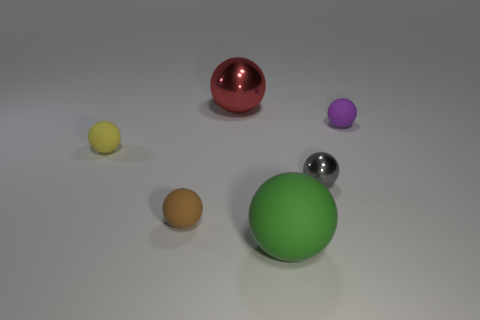Subtract 1 balls. How many balls are left? 5 Subtract all gray spheres. How many spheres are left? 5 Subtract all green rubber balls. How many balls are left? 5 Subtract all cyan balls. Subtract all brown cylinders. How many balls are left? 6 Add 4 small metallic spheres. How many objects exist? 10 Add 6 brown rubber spheres. How many brown rubber spheres exist? 7 Subtract 0 green cubes. How many objects are left? 6 Subtract all gray shiny spheres. Subtract all blue rubber spheres. How many objects are left? 5 Add 3 small yellow matte spheres. How many small yellow matte spheres are left? 4 